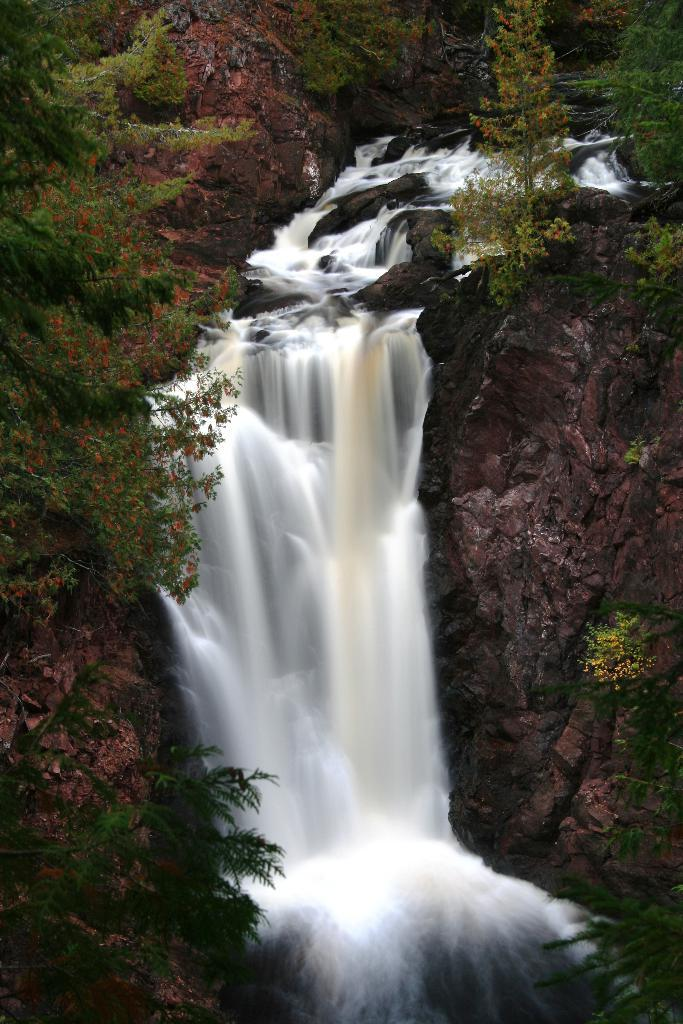What is the main feature in the center of the image? There is a waterfall in the center of the image. What can be seen on the right side of the image? There are rocks on the right side of the image. What type of vegetation is on the left side of the image? There are trees on the left side of the image. Where is the sister sitting in the image? There is no sister present in the image. What type of machine can be seen operating near the waterfall? There is no machine present in the image. 